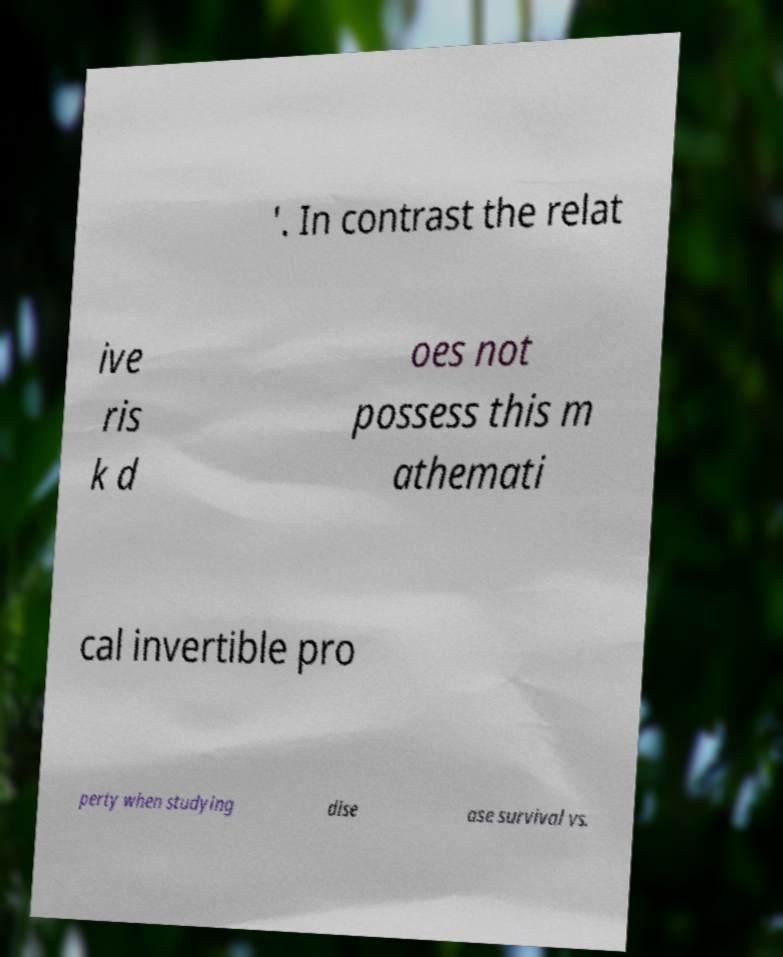Can you read and provide the text displayed in the image?This photo seems to have some interesting text. Can you extract and type it out for me? '. In contrast the relat ive ris k d oes not possess this m athemati cal invertible pro perty when studying dise ase survival vs. 